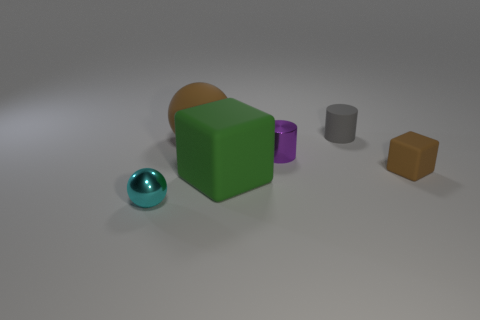Do the rubber sphere and the tiny matte block have the same color?
Give a very brief answer. Yes. What shape is the matte object that is the same color as the large matte sphere?
Make the answer very short. Cube. What number of other small objects are the same shape as the small purple metallic thing?
Give a very brief answer. 1. The rubber cylinder that is the same size as the cyan object is what color?
Give a very brief answer. Gray. The small matte object to the right of the cylinder that is behind the metallic object behind the cyan ball is what color?
Your answer should be very brief. Brown. There is a green rubber thing; is it the same size as the metallic object that is in front of the tiny cube?
Make the answer very short. No. How many objects are large brown balls or tiny purple shiny objects?
Give a very brief answer. 2. Are there any large yellow blocks that have the same material as the tiny gray object?
Give a very brief answer. No. There is a matte cube that is the same color as the large ball; what is its size?
Keep it short and to the point. Small. What color is the large object that is behind the small object on the right side of the rubber cylinder?
Ensure brevity in your answer.  Brown. 